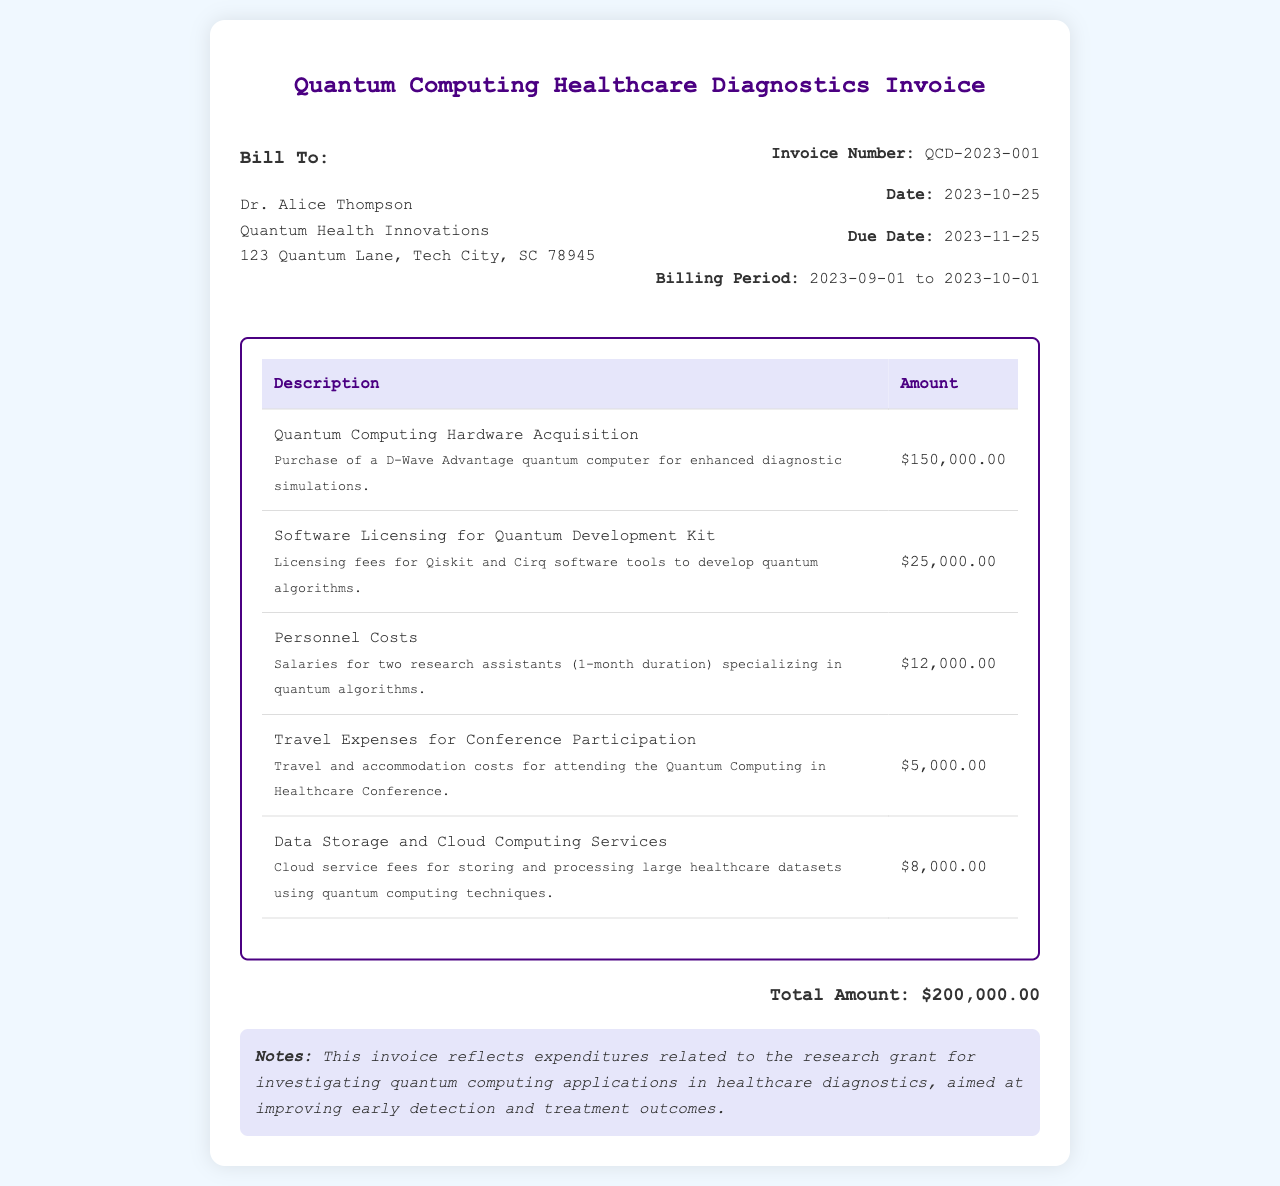What is the invoice number? The invoice number is clearly stated in the document and is used for tracking financial records.
Answer: QCD-2023-001 What is the total amount? The total amount is the sum of all listed expenditures in the invoice.
Answer: $200,000.00 Who is the bill recipient? The bill recipient's name and organization are provided in the invoice header.
Answer: Dr. Alice Thompson What was purchased for enhanced diagnostic simulations? The description indicates a specific item acquired for quantum computing healthcare applications.
Answer: D-Wave Advantage quantum computer What are the dates for the billing period? The billing period provides the time frame for the reported expenditures.
Answer: 2023-09-01 to 2023-10-01 How much was allocated for personnel costs? The invoice outlines individual expenditure categories, including personnel costs.
Answer: $12,000.00 What are the travel expenses for? The travel expenses describe the purpose of the funding allocated.
Answer: Conference Participation What does the noted invoice reflect? The notes section summarizes the overall purpose of the expenditures listed.
Answer: Research grant expenditures How many research assistants were funded? The personnel costs section specifies the number of individuals accounted for in that expenditure.
Answer: Two 